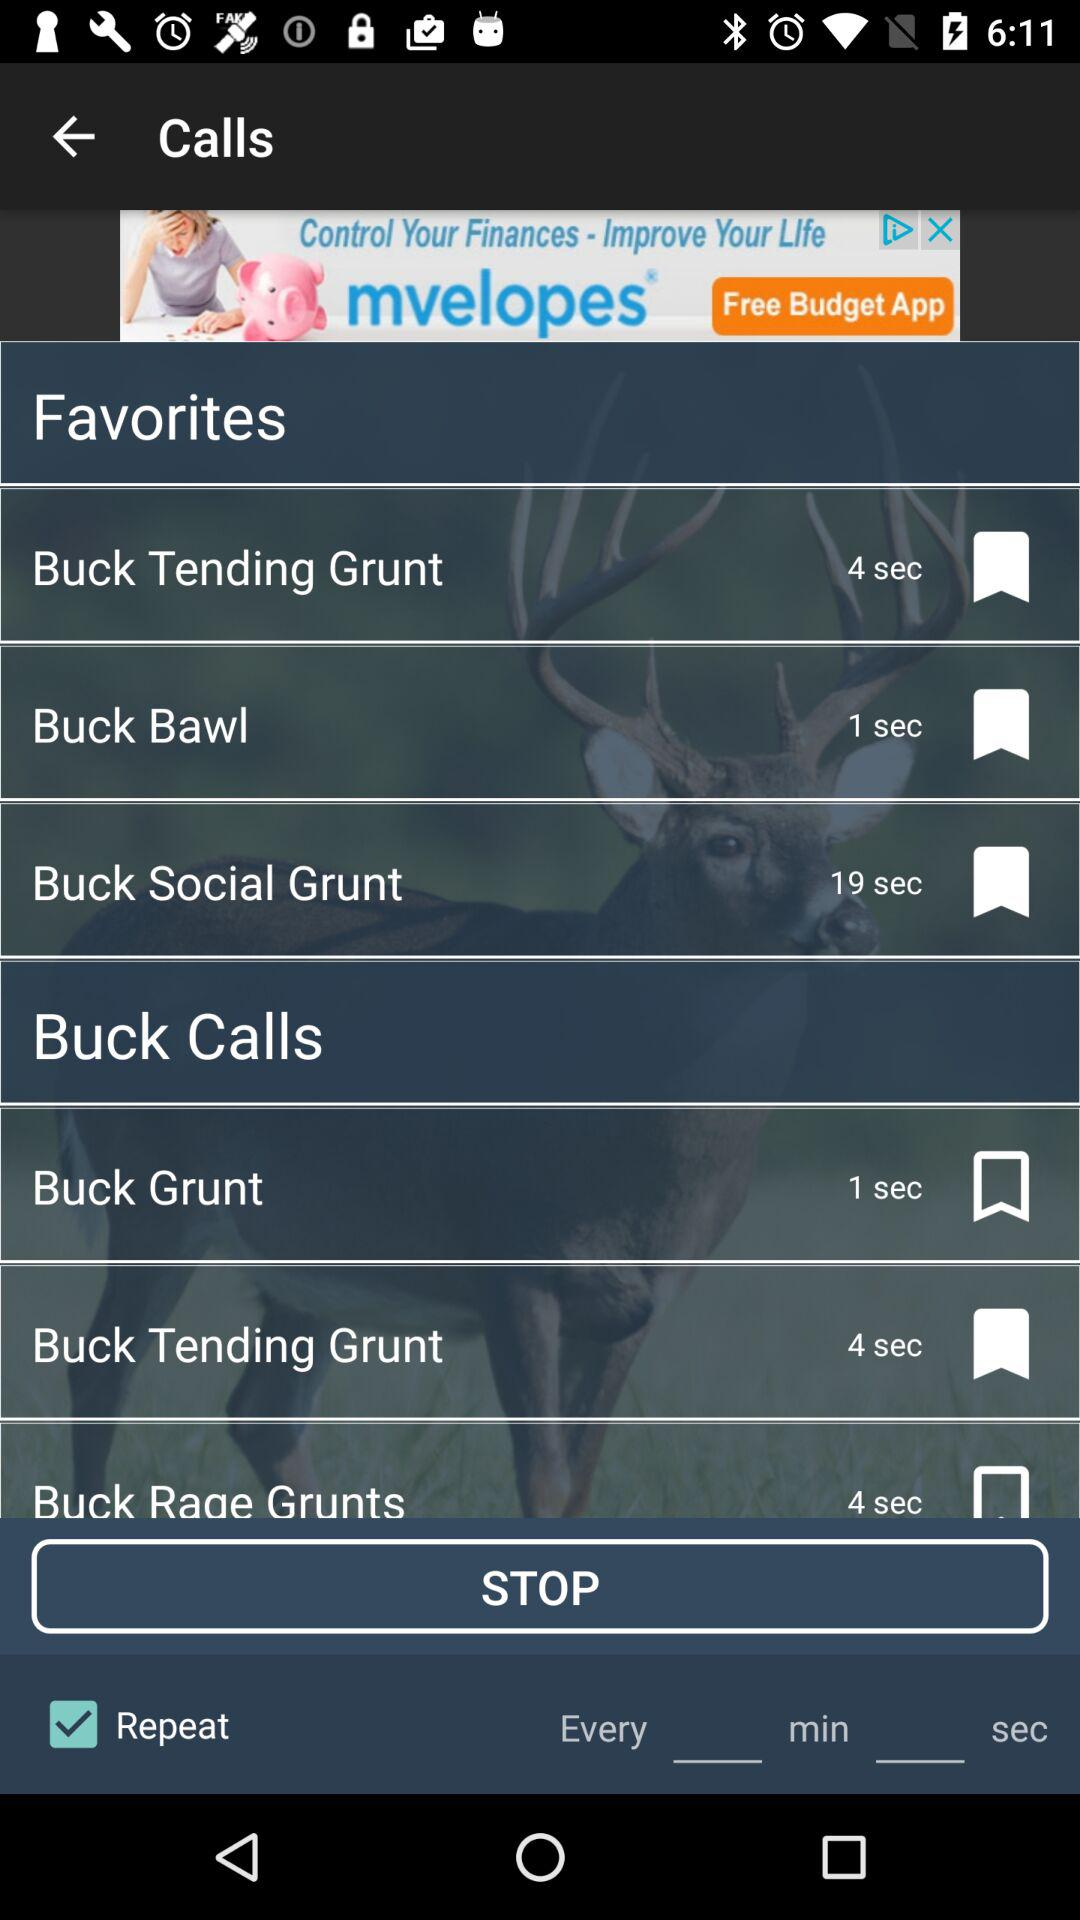What is the status of "Repeat" calls? The status is "on". 